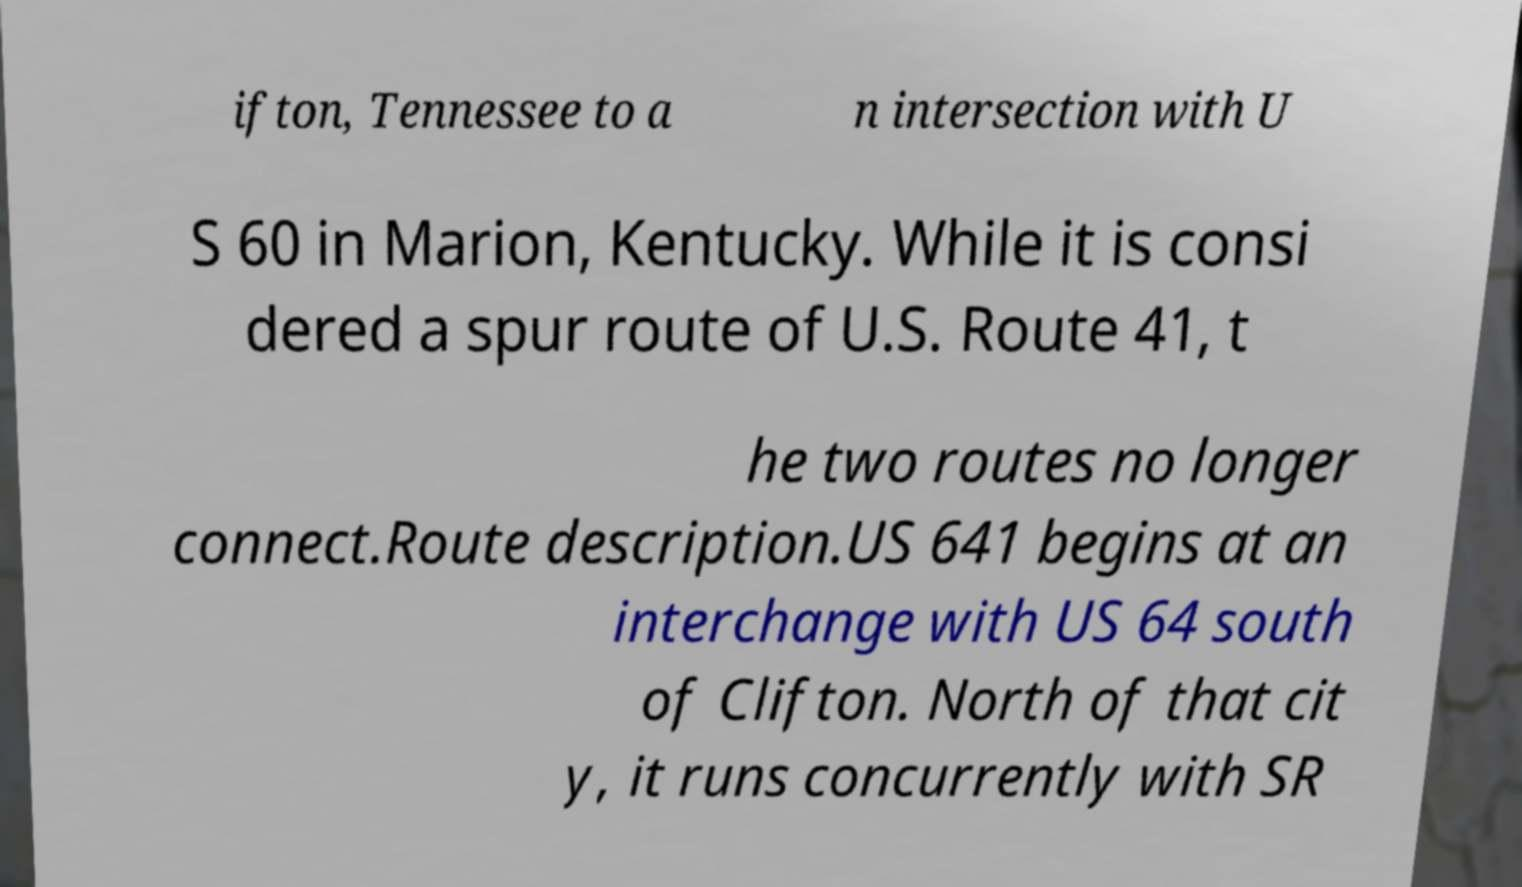Can you accurately transcribe the text from the provided image for me? ifton, Tennessee to a n intersection with U S 60 in Marion, Kentucky. While it is consi dered a spur route of U.S. Route 41, t he two routes no longer connect.Route description.US 641 begins at an interchange with US 64 south of Clifton. North of that cit y, it runs concurrently with SR 